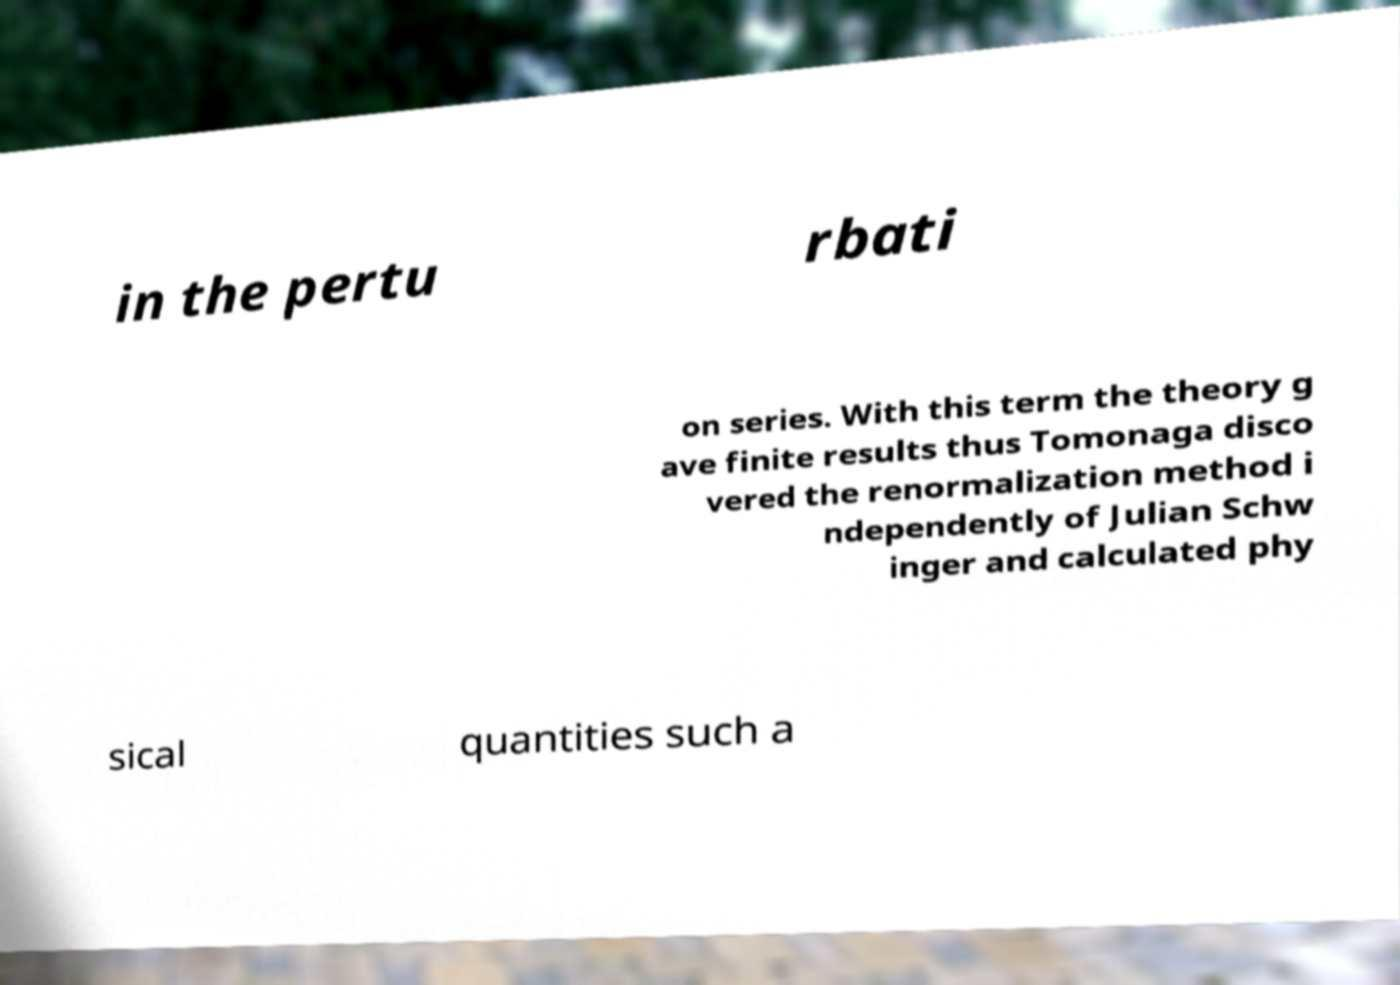Please identify and transcribe the text found in this image. in the pertu rbati on series. With this term the theory g ave finite results thus Tomonaga disco vered the renormalization method i ndependently of Julian Schw inger and calculated phy sical quantities such a 